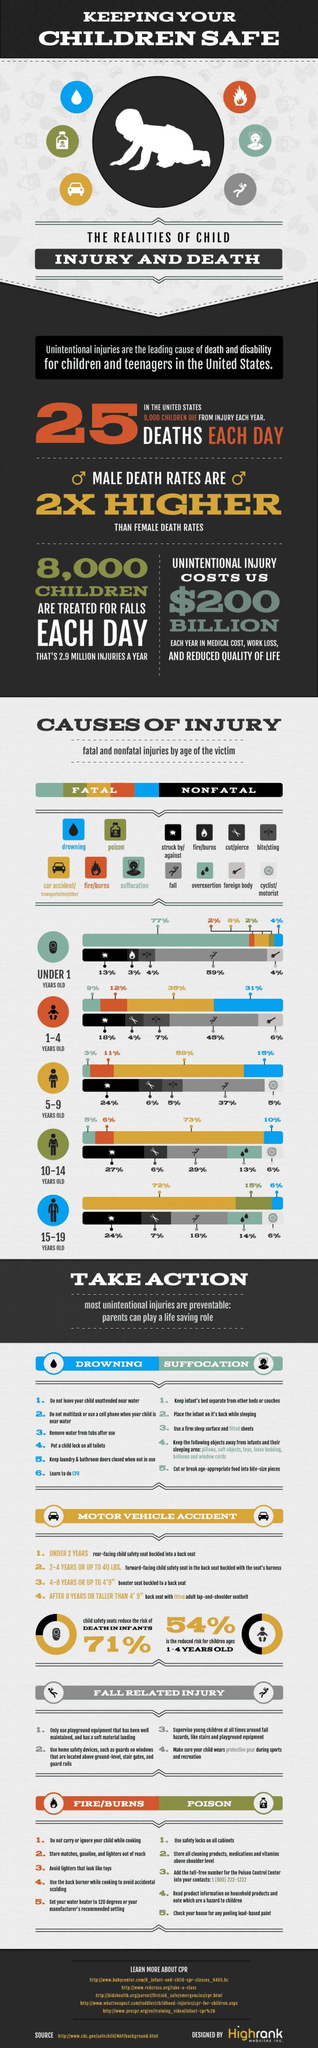Draw attention to some important aspects in this diagram. Nonfatal injuries are the most common cause of injury for children aged 1-4 years old in the United States, and falls are the major cause of these injuries, according to recent studies. The major cause of fatal injuries for children aged 15-19 years old in the United States is car accidents, followed by transportation accidents and other causes. The major cause of fatal injuries for children under the age of 1 in the United States is suffocation. In the United States, 37% of children aged 5-9 years old were injured by falls, according to recent data. In the United States, 31% of children aged 1-4 years old were killed by drowning. 